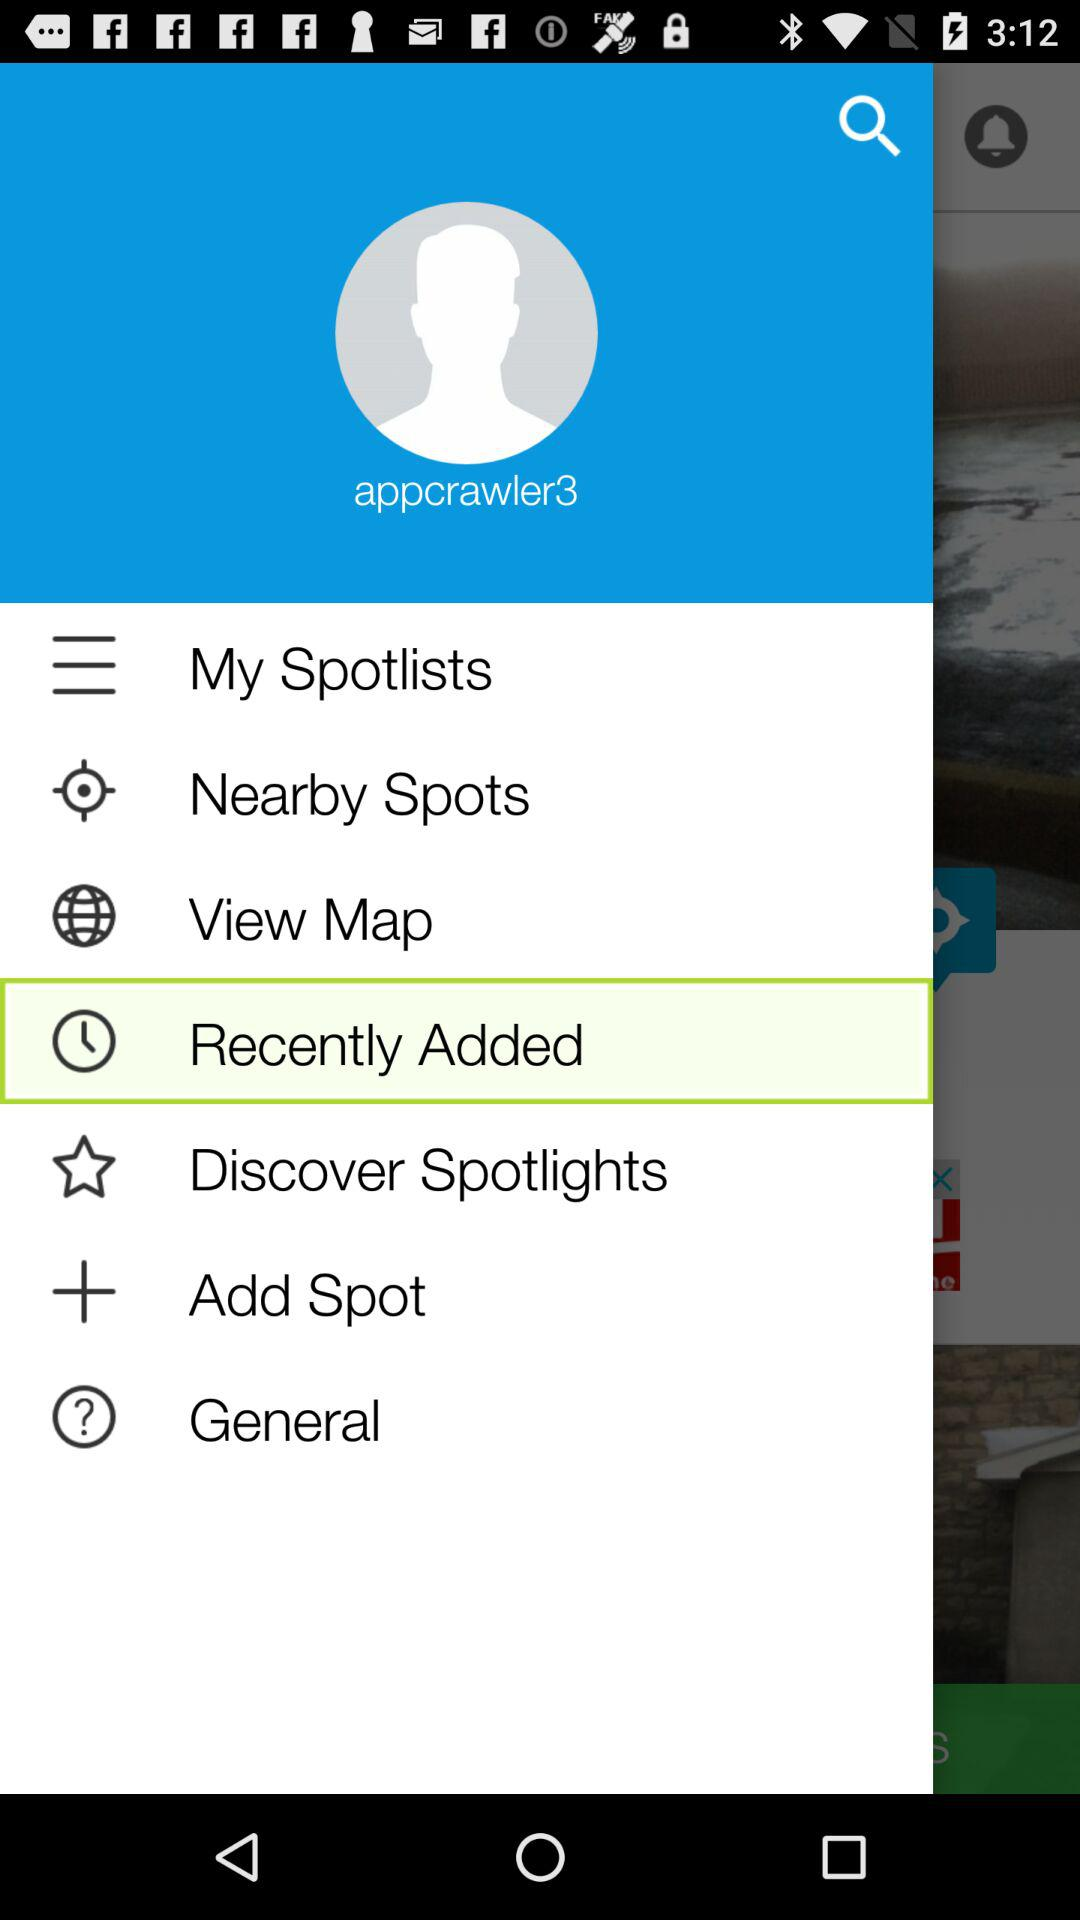Which item is selected? The selected item is "Recently Added". 